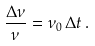<formula> <loc_0><loc_0><loc_500><loc_500>\frac { \Delta \nu } { \nu } = \nu _ { 0 } \, \Delta t \, .</formula> 